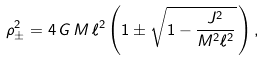Convert formula to latex. <formula><loc_0><loc_0><loc_500><loc_500>\rho ^ { 2 } _ { \pm } = 4 \, G \, M \, \ell ^ { 2 } \left ( 1 \pm \sqrt { 1 - \frac { J ^ { 2 } } { M ^ { 2 } \ell ^ { 2 } } } \, \right ) ,</formula> 